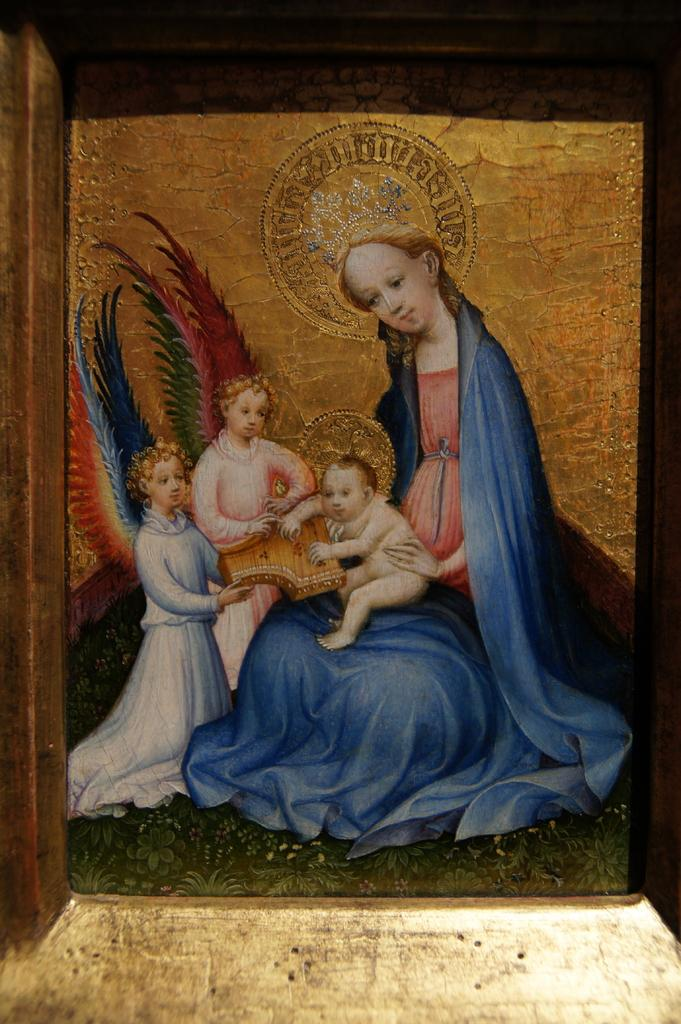Who is present in the image? There is a woman in the image. What is the woman doing in the image? The woman is holding a child. How many children are in the image? There are two children in the image. What type of game is being played in the office in the image? There is no game or office present in the image; it features a woman holding a child and another child nearby. 